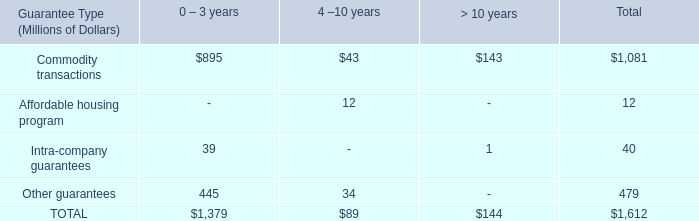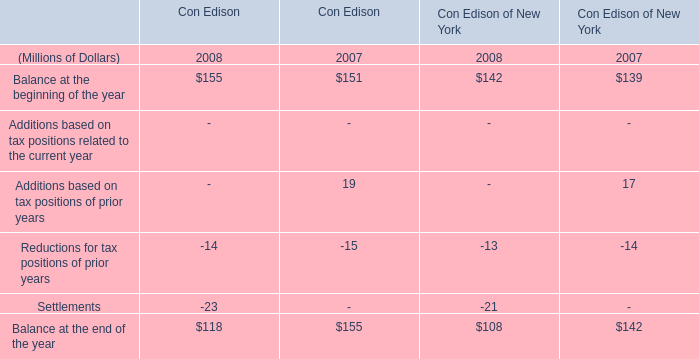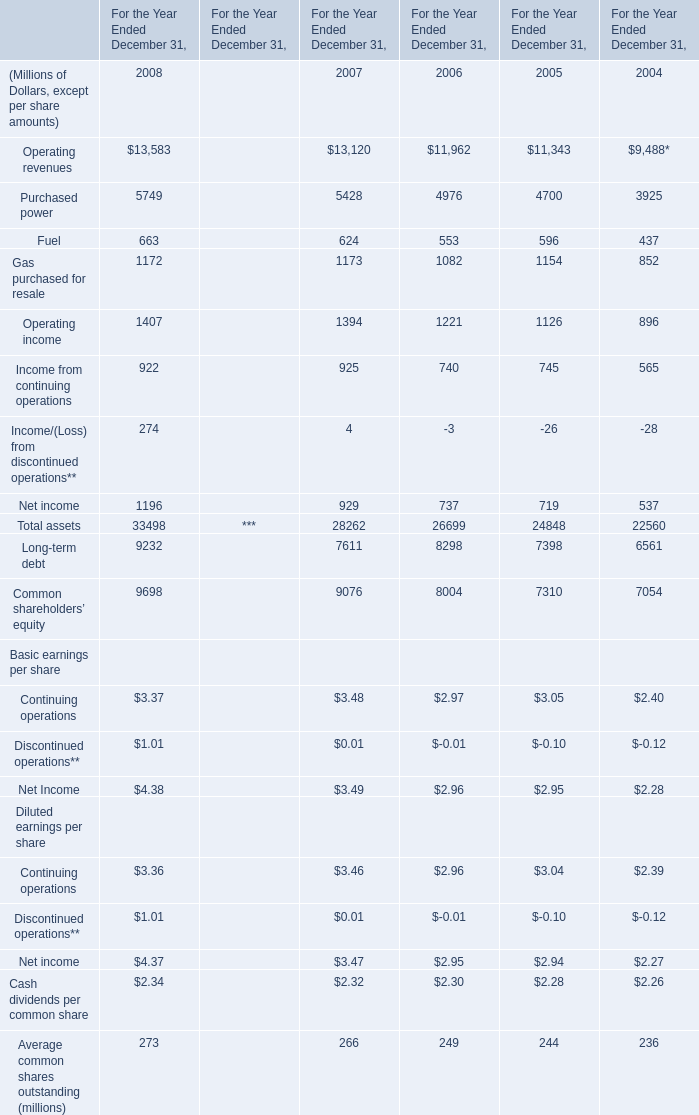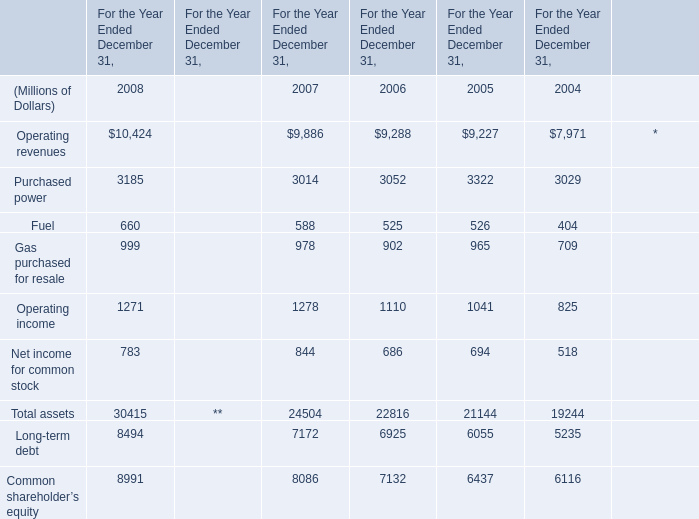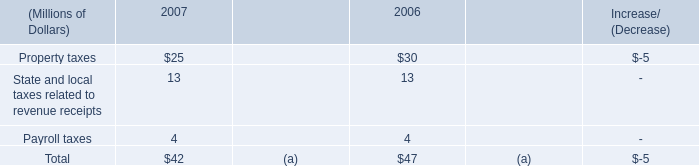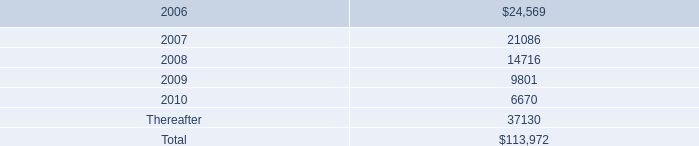What is the total value of Operating revenues, Purchased power, Fuel and Gas purchased for resale in in 2008? (in million) 
Computations: (((13583 + 5749) + 663) + 1172)
Answer: 21167.0. 